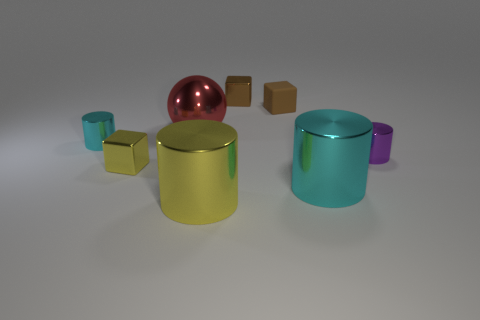Subtract all tiny brown metallic cubes. How many cubes are left? 2 Add 2 tiny purple cylinders. How many objects exist? 10 Subtract all purple cylinders. How many cylinders are left? 3 Subtract all balls. How many objects are left? 7 Subtract 1 spheres. How many spheres are left? 0 Subtract all cyan cubes. How many cyan balls are left? 0 Subtract all purple objects. Subtract all purple metallic things. How many objects are left? 6 Add 8 red metal balls. How many red metal balls are left? 9 Add 2 small metallic things. How many small metallic things exist? 6 Subtract 0 blue balls. How many objects are left? 8 